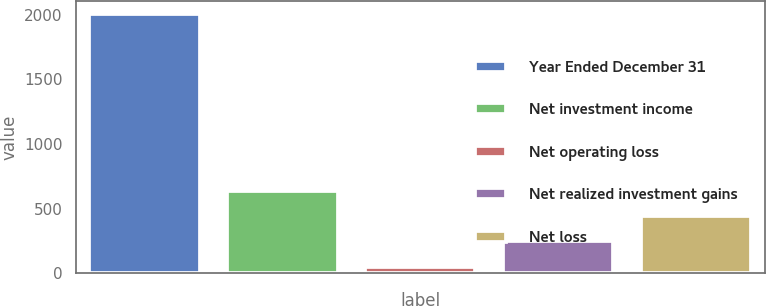Convert chart to OTSL. <chart><loc_0><loc_0><loc_500><loc_500><bar_chart><fcel>Year Ended December 31<fcel>Net investment income<fcel>Net operating loss<fcel>Net realized investment gains<fcel>Net loss<nl><fcel>2008<fcel>637.4<fcel>50<fcel>245.8<fcel>441.6<nl></chart> 